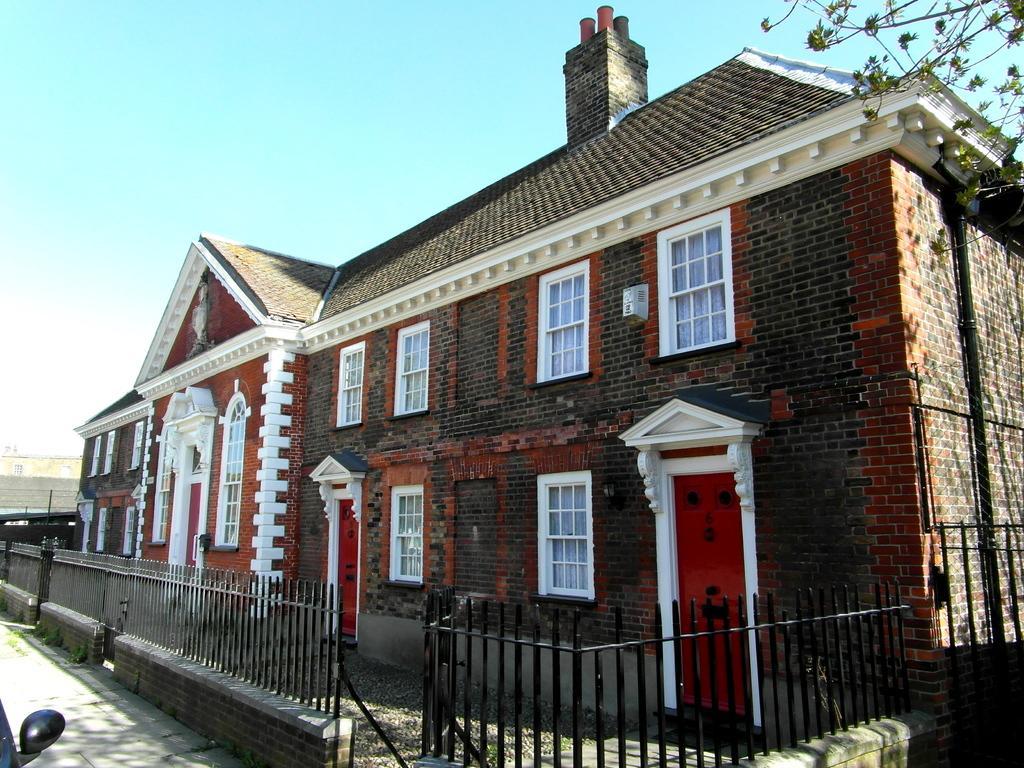How would you summarize this image in a sentence or two? In this picture there are buildings. In the foreground there is a railing and there is a vehicle on the road. On the right side of the image there is a tree and there is a pipe on the wall and there are curtains behind the windows. At the top there is sky. At the bottom there is a road and there is grass. 